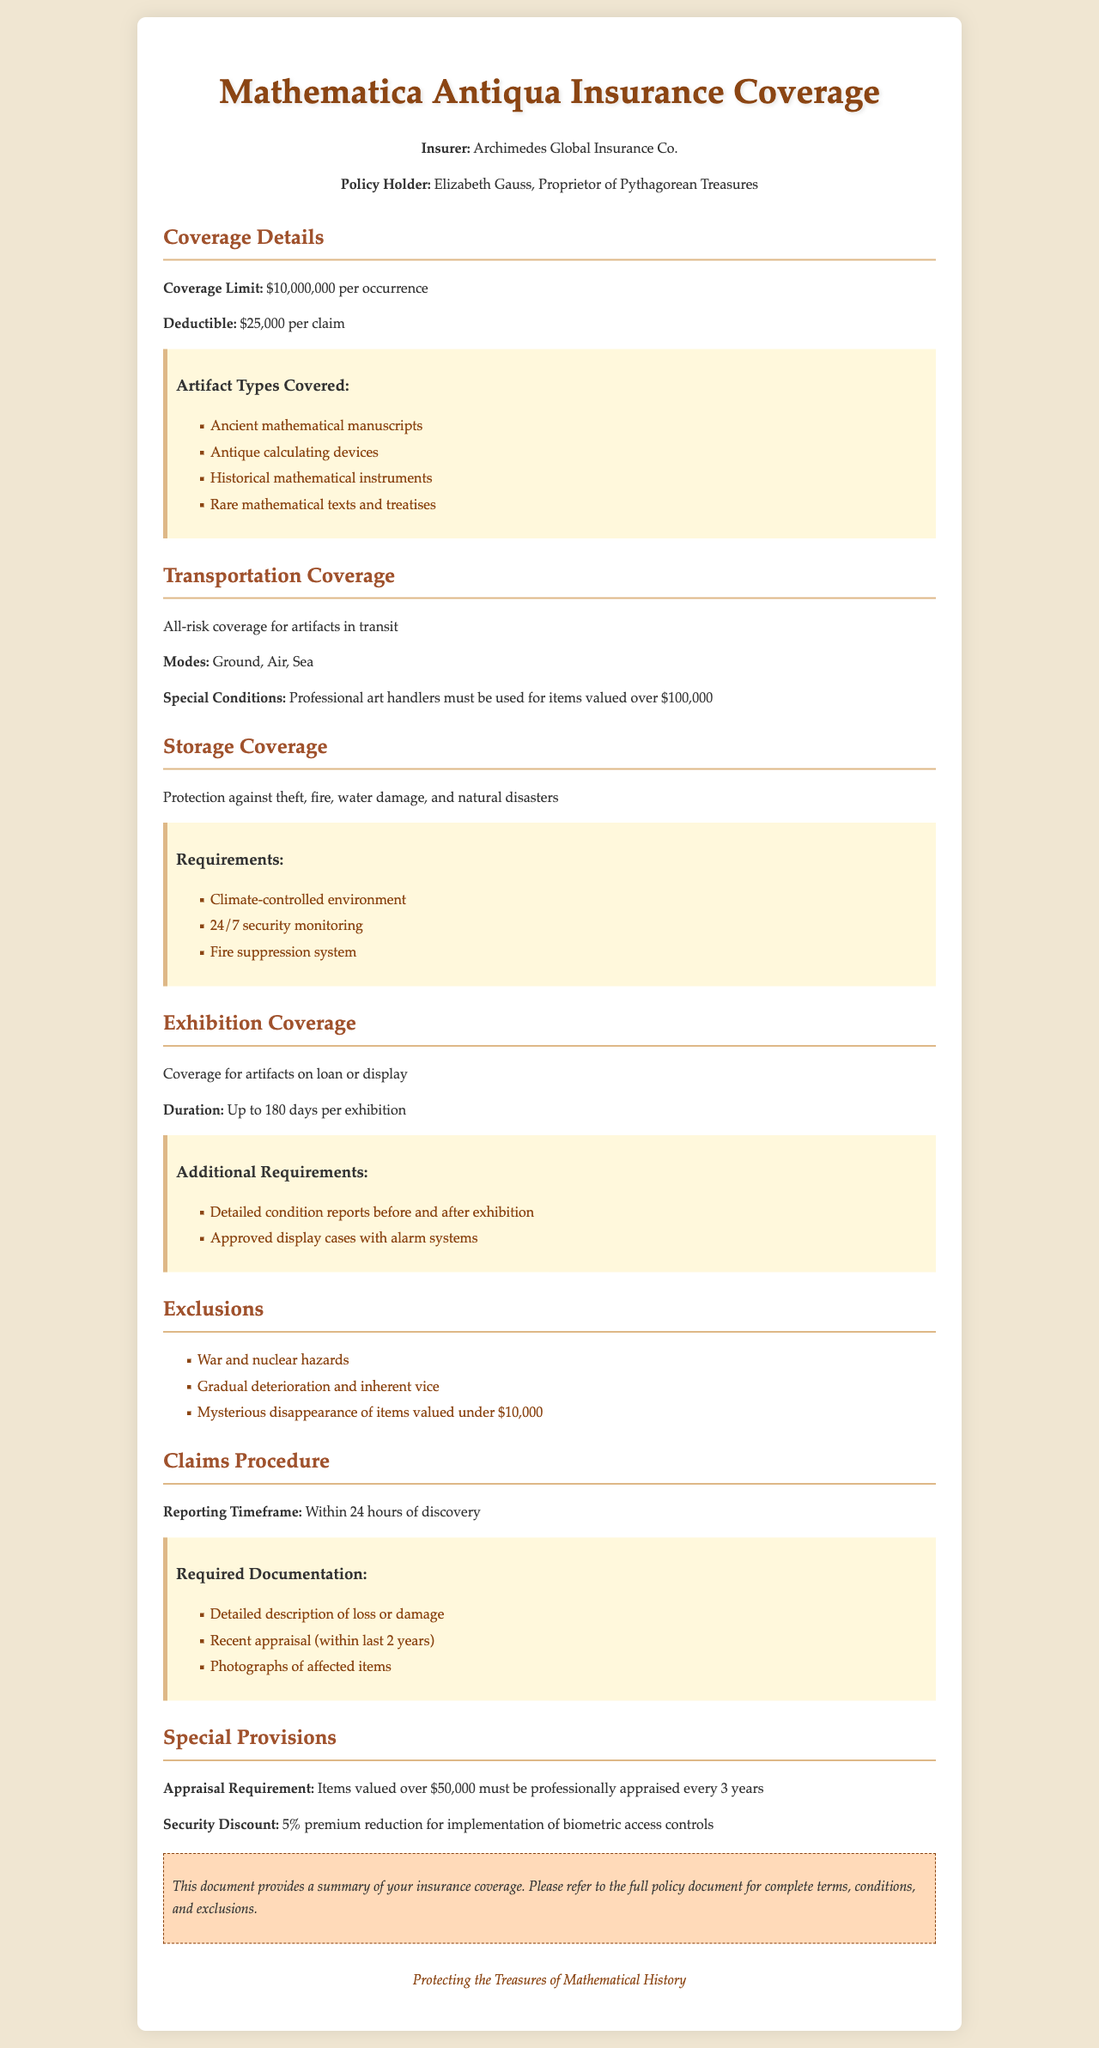What is the coverage limit? The coverage limit is stated in the document under coverage details, which is $10,000,000 per occurrence.
Answer: $10,000,000 Who is the policy holder? The policy holder's name is mentioned in the header information section, which is Elizabeth Gauss.
Answer: Elizabeth Gauss What is the deductible amount? The deductible amount is included in the coverage details section, which is $25,000 per claim.
Answer: $25,000 What types of artifacts are covered? The document lists the types of artifacts covered under the coverage item, which includes ancient mathematical manuscripts, antique calculating devices, historical mathematical instruments, and rare mathematical texts and treatises.
Answer: Ancient mathematical manuscripts, antique calculating devices, historical mathematical instruments, rare mathematical texts and treatises What are special conditions for transportation? The special conditions for transportation coverage are specified, stating that professional art handlers must be used for items valued over $100,000.
Answer: Professional art handlers must be used for items valued over $100,000 What is the duration of exhibition coverage? This information is provided in the exhibition coverage section, indicating the duration is up to 180 days per exhibition.
Answer: Up to 180 days What is excluded from the policy? The document lists exclusions, including war and nuclear hazards, gradual deterioration and inherent vice, and mysterious disappearance of items valued under $10,000.
Answer: War and nuclear hazards, gradual deterioration and inherent vice, mysterious disappearance of items valued under $10,000 What reporting timeframe is required for claims? The reporting timeframe is specified in the claims procedure section, stating that it must be reported within 24 hours of discovery.
Answer: Within 24 hours What is the appraisal requirement for high-value items? The appraisal requirement is stated under special provisions, that items valued over $50,000 must be professionally appraised every 3 years.
Answer: Professionally appraised every 3 years 